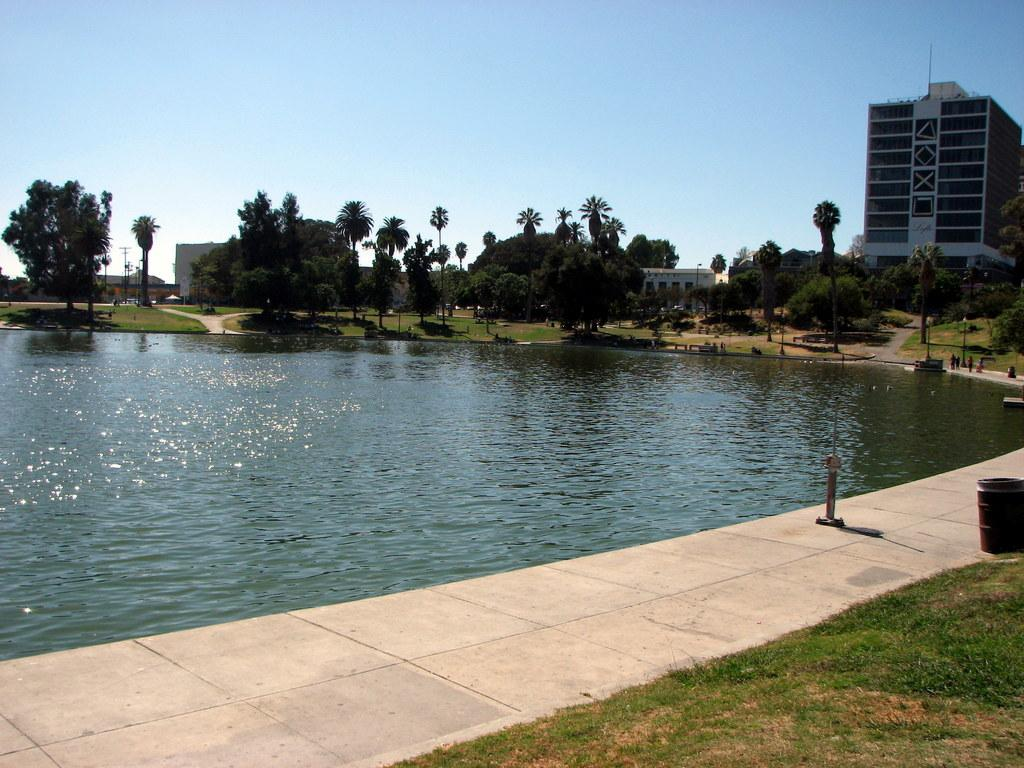What is the primary element visible in the image? There is water in the image. What type of vegetation can be seen in the image? There are trees and grass in the image. What type of structures are present in the image? There are buildings in the image. What is visible in the background of the image? The sky is visible in the background of the image. Can you tell me how many bones are present in the image? There are no bones visible in the image. 